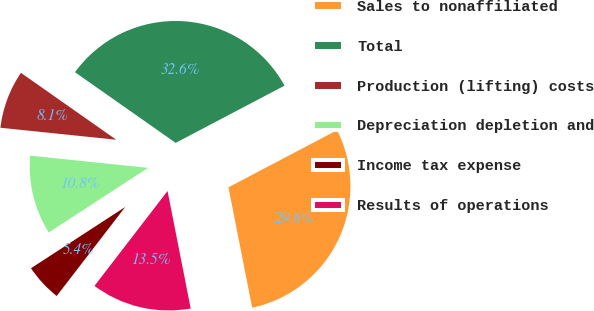<chart> <loc_0><loc_0><loc_500><loc_500><pie_chart><fcel>Sales to nonaffiliated<fcel>Total<fcel>Production (lifting) costs<fcel>Depreciation depletion and<fcel>Income tax expense<fcel>Results of operations<nl><fcel>29.61%<fcel>32.56%<fcel>8.1%<fcel>10.82%<fcel>5.38%<fcel>13.54%<nl></chart> 